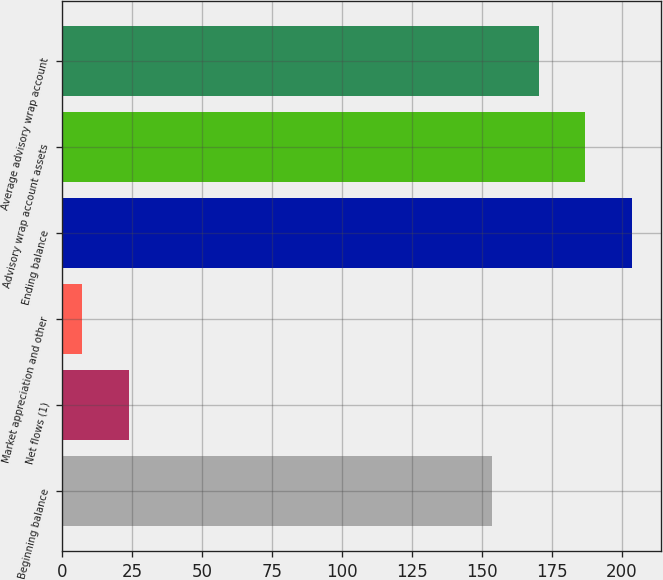<chart> <loc_0><loc_0><loc_500><loc_500><bar_chart><fcel>Beginning balance<fcel>Net flows (1)<fcel>Market appreciation and other<fcel>Ending balance<fcel>Advisory wrap account assets<fcel>Average advisory wrap account<nl><fcel>153.5<fcel>23.77<fcel>7<fcel>203.81<fcel>187.04<fcel>170.27<nl></chart> 